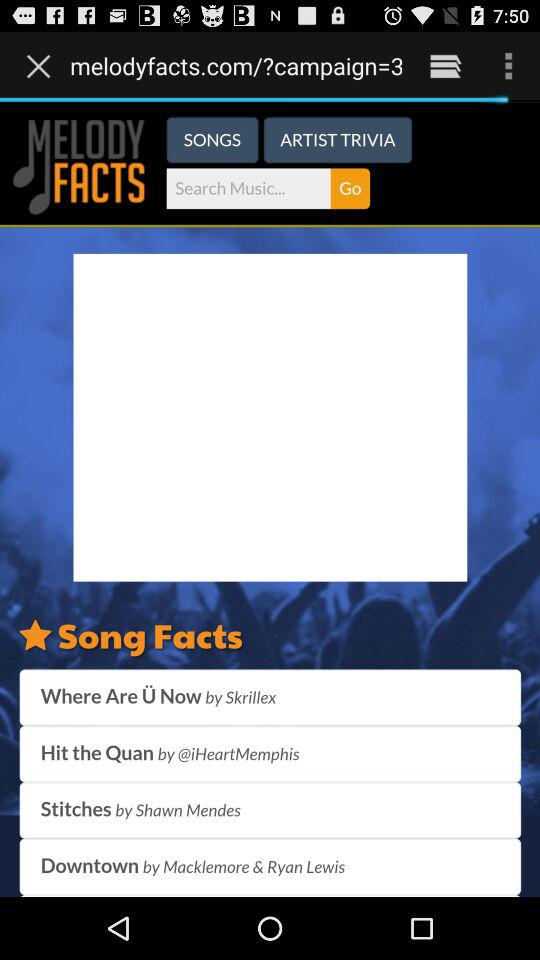What is the application name?
When the provided information is insufficient, respond with <no answer>. <no answer> 